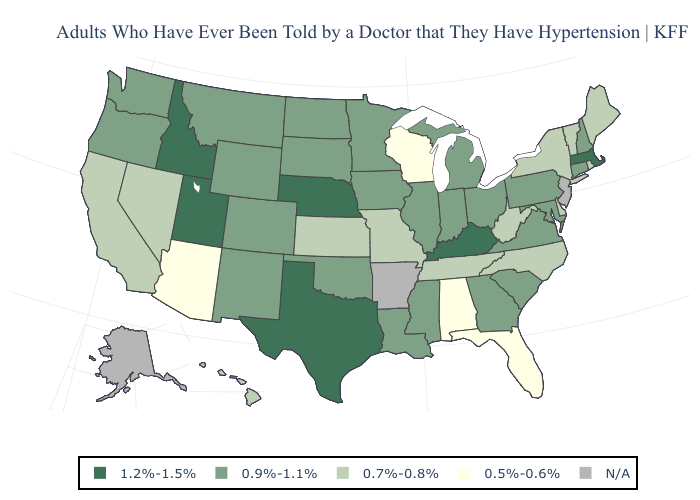Name the states that have a value in the range 0.5%-0.6%?
Answer briefly. Alabama, Arizona, Florida, Wisconsin. Name the states that have a value in the range N/A?
Short answer required. Alaska, Arkansas, New Jersey. Which states have the highest value in the USA?
Short answer required. Idaho, Kentucky, Massachusetts, Nebraska, Texas, Utah. What is the highest value in states that border Arizona?
Quick response, please. 1.2%-1.5%. Does the map have missing data?
Give a very brief answer. Yes. What is the lowest value in the USA?
Quick response, please. 0.5%-0.6%. Among the states that border Vermont , does Massachusetts have the lowest value?
Keep it brief. No. Name the states that have a value in the range 1.2%-1.5%?
Short answer required. Idaho, Kentucky, Massachusetts, Nebraska, Texas, Utah. What is the value of Tennessee?
Write a very short answer. 0.7%-0.8%. How many symbols are there in the legend?
Quick response, please. 5. Does California have the highest value in the West?
Answer briefly. No. What is the value of Delaware?
Quick response, please. 0.7%-0.8%. What is the value of Maine?
Quick response, please. 0.7%-0.8%. Name the states that have a value in the range 0.5%-0.6%?
Quick response, please. Alabama, Arizona, Florida, Wisconsin. 